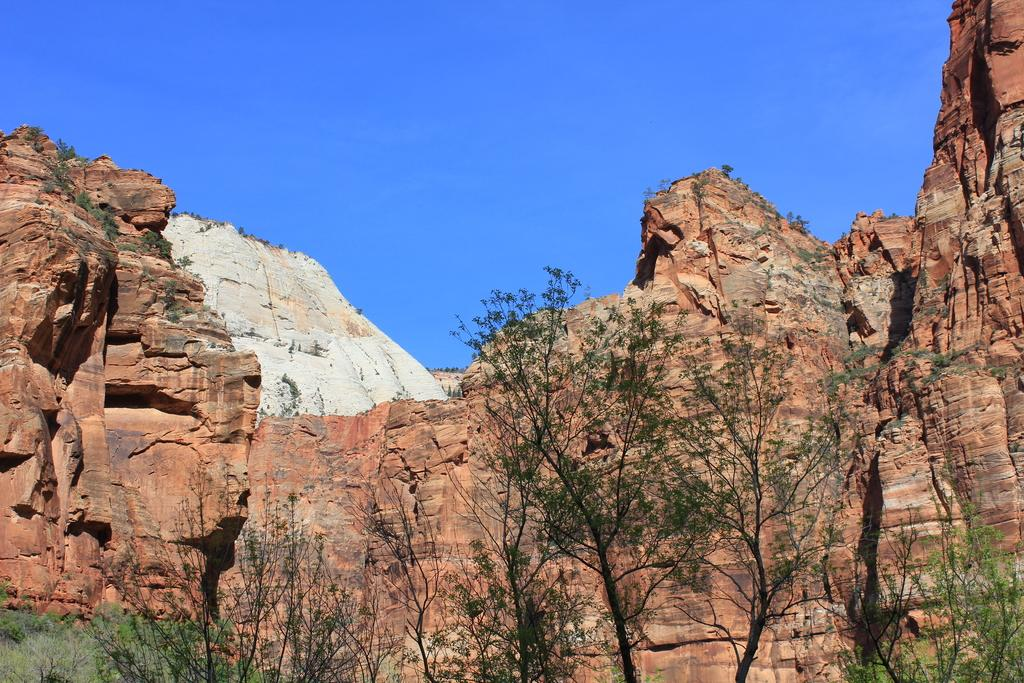What is the color of the rock in the image? The rock in the image has a brown and white color. What type of vegetation can be seen in the image? There are trees in the image. What color is the sky in the image? The sky is blue in the image. Where is the sofa located in the image? There is no sofa present in the image. What type of note is attached to the branch in the image? There is no branch or note present in the image. 